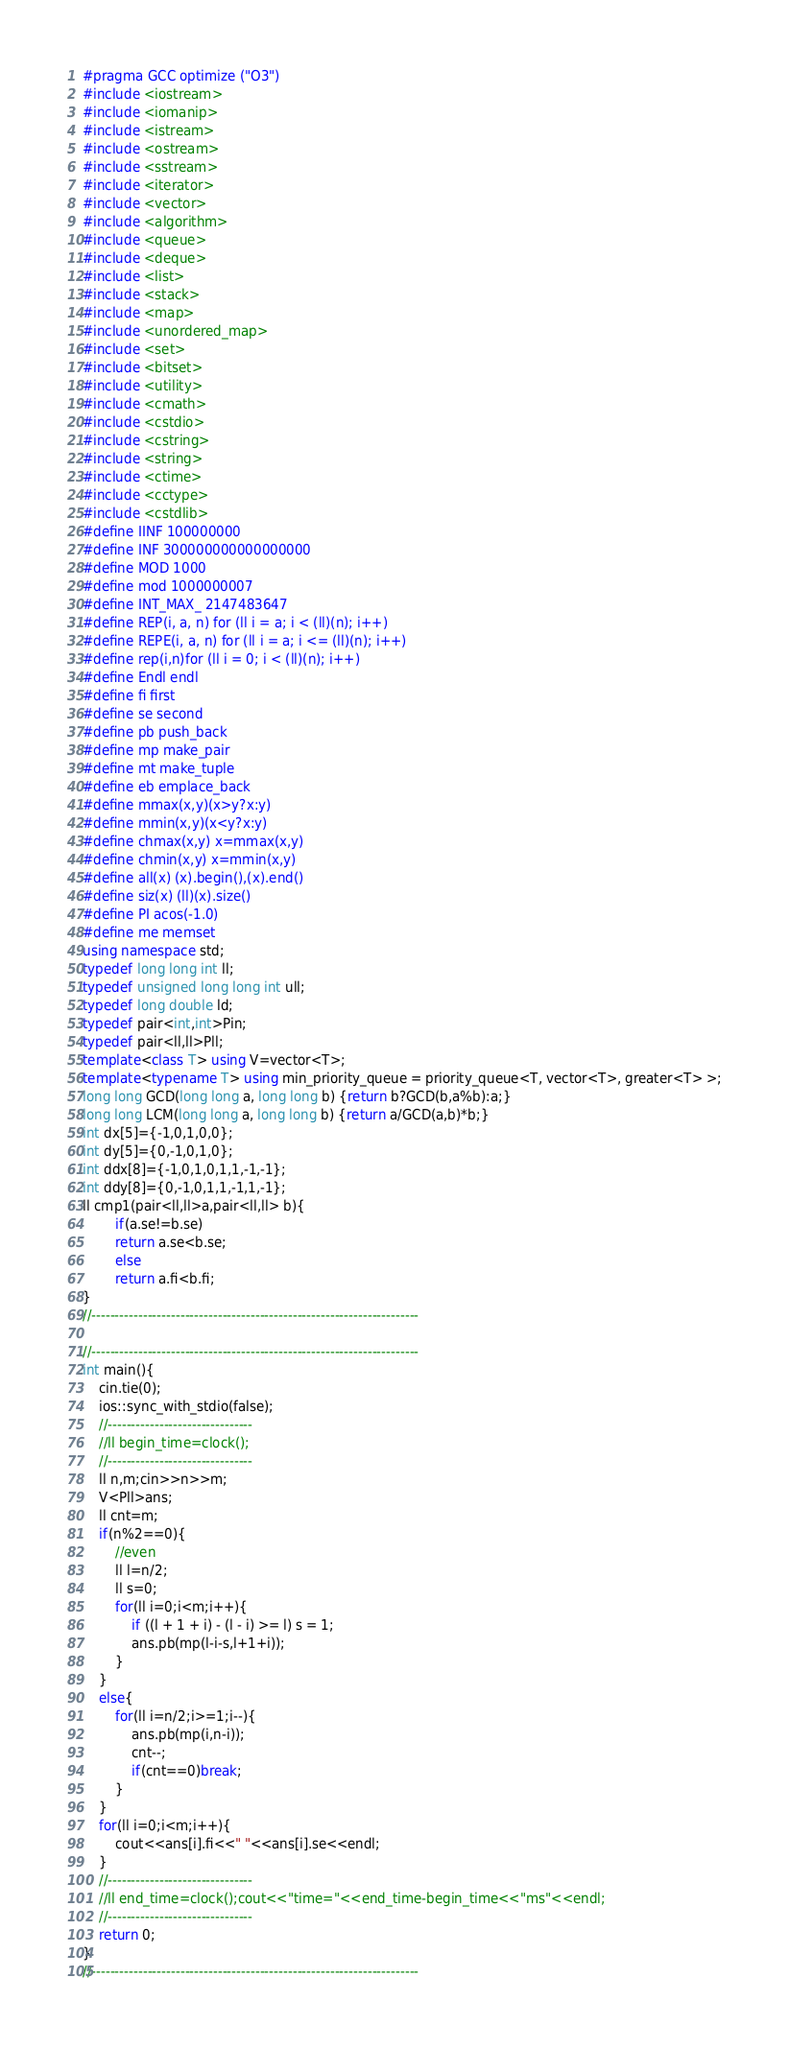<code> <loc_0><loc_0><loc_500><loc_500><_C++_>#pragma GCC optimize ("O3")
#include <iostream>
#include <iomanip>
#include <istream>
#include <ostream>
#include <sstream>
#include <iterator>
#include <vector>
#include <algorithm>
#include <queue>
#include <deque>
#include <list>
#include <stack>
#include <map>
#include <unordered_map>
#include <set>
#include <bitset>
#include <utility>
#include <cmath>
#include <cstdio>
#include <cstring>
#include <string>
#include <ctime>
#include <cctype>
#include <cstdlib>
#define IINF 100000000
#define INF 300000000000000000
#define MOD 1000
#define mod 1000000007
#define INT_MAX_ 2147483647
#define REP(i, a, n) for (ll i = a; i < (ll)(n); i++)
#define REPE(i, a, n) for (ll i = a; i <= (ll)(n); i++)
#define rep(i,n)for (ll i = 0; i < (ll)(n); i++)
#define Endl endl
#define fi first
#define se second
#define pb push_back
#define mp make_pair
#define mt make_tuple
#define eb emplace_back
#define mmax(x,y)(x>y?x:y)
#define mmin(x,y)(x<y?x:y)
#define chmax(x,y) x=mmax(x,y)
#define chmin(x,y) x=mmin(x,y)
#define all(x) (x).begin(),(x).end()
#define siz(x) (ll)(x).size()
#define PI acos(-1.0)
#define me memset
using namespace std;
typedef long long int ll;
typedef unsigned long long int ull;
typedef long double ld;
typedef pair<int,int>Pin;
typedef pair<ll,ll>Pll;
template<class T> using V=vector<T>;
template<typename T> using min_priority_queue = priority_queue<T, vector<T>, greater<T> >;
long long GCD(long long a, long long b) {return b?GCD(b,a%b):a;}
long long LCM(long long a, long long b) {return a/GCD(a,b)*b;}
int dx[5]={-1,0,1,0,0};
int dy[5]={0,-1,0,1,0};
int ddx[8]={-1,0,1,0,1,1,-1,-1};
int ddy[8]={0,-1,0,1,1,-1,1,-1};
ll cmp1(pair<ll,ll>a,pair<ll,ll> b){
        if(a.se!=b.se)
        return a.se<b.se;
        else
        return a.fi<b.fi;
}
//----------------------------------------------------------------------

//----------------------------------------------------------------------
int main(){
    cin.tie(0);
    ios::sync_with_stdio(false);
    //-------------------------------  
    //ll begin_time=clock();
    //-------------------------------
    ll n,m;cin>>n>>m;
    V<Pll>ans;
    ll cnt=m;
    if(n%2==0){
        //even
        ll l=n/2;
        ll s=0;
        for(ll i=0;i<m;i++){
            if ((l + 1 + i) - (l - i) >= l) s = 1;
            ans.pb(mp(l-i-s,l+1+i));
        }
    }
    else{
        for(ll i=n/2;i>=1;i--){
            ans.pb(mp(i,n-i));
            cnt--;
            if(cnt==0)break;
        }
    }
    for(ll i=0;i<m;i++){
        cout<<ans[i].fi<<" "<<ans[i].se<<endl;
    }
    //-------------------------------  
    //ll end_time=clock();cout<<"time="<<end_time-begin_time<<"ms"<<endl;
    //-------------------------------
    return 0;
}
//----------------------------------------------------------------------



































</code> 